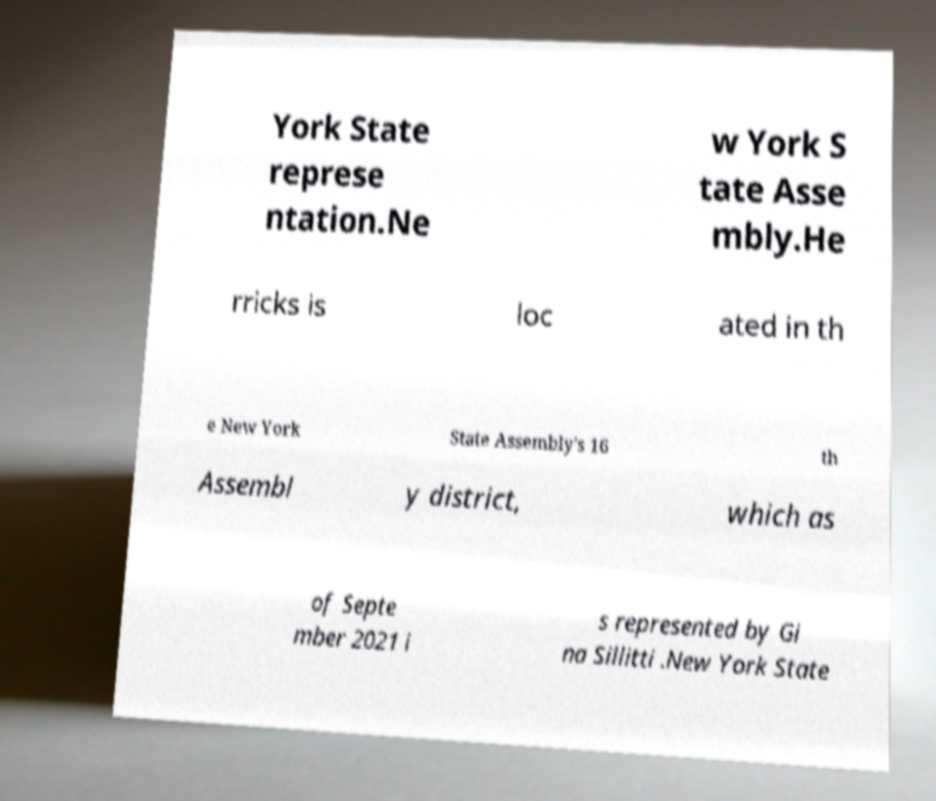There's text embedded in this image that I need extracted. Can you transcribe it verbatim? York State represe ntation.Ne w York S tate Asse mbly.He rricks is loc ated in th e New York State Assembly's 16 th Assembl y district, which as of Septe mber 2021 i s represented by Gi na Sillitti .New York State 